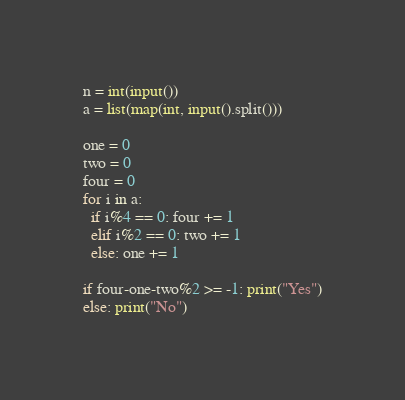<code> <loc_0><loc_0><loc_500><loc_500><_Python_>n = int(input())
a = list(map(int, input().split()))

one = 0
two = 0
four = 0
for i in a:
  if i%4 == 0: four += 1
  elif i%2 == 0: two += 1
  else: one += 1

if four-one-two%2 >= -1: print("Yes")
else: print("No")</code> 